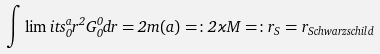<formula> <loc_0><loc_0><loc_500><loc_500>\int \lim i t s _ { 0 } ^ { a } r ^ { 2 } G ^ { 0 } _ { 0 } d r = 2 m ( a ) = \colon 2 \varkappa M = \colon r _ { S } = r _ { S c h w a r z s c h i l d }</formula> 